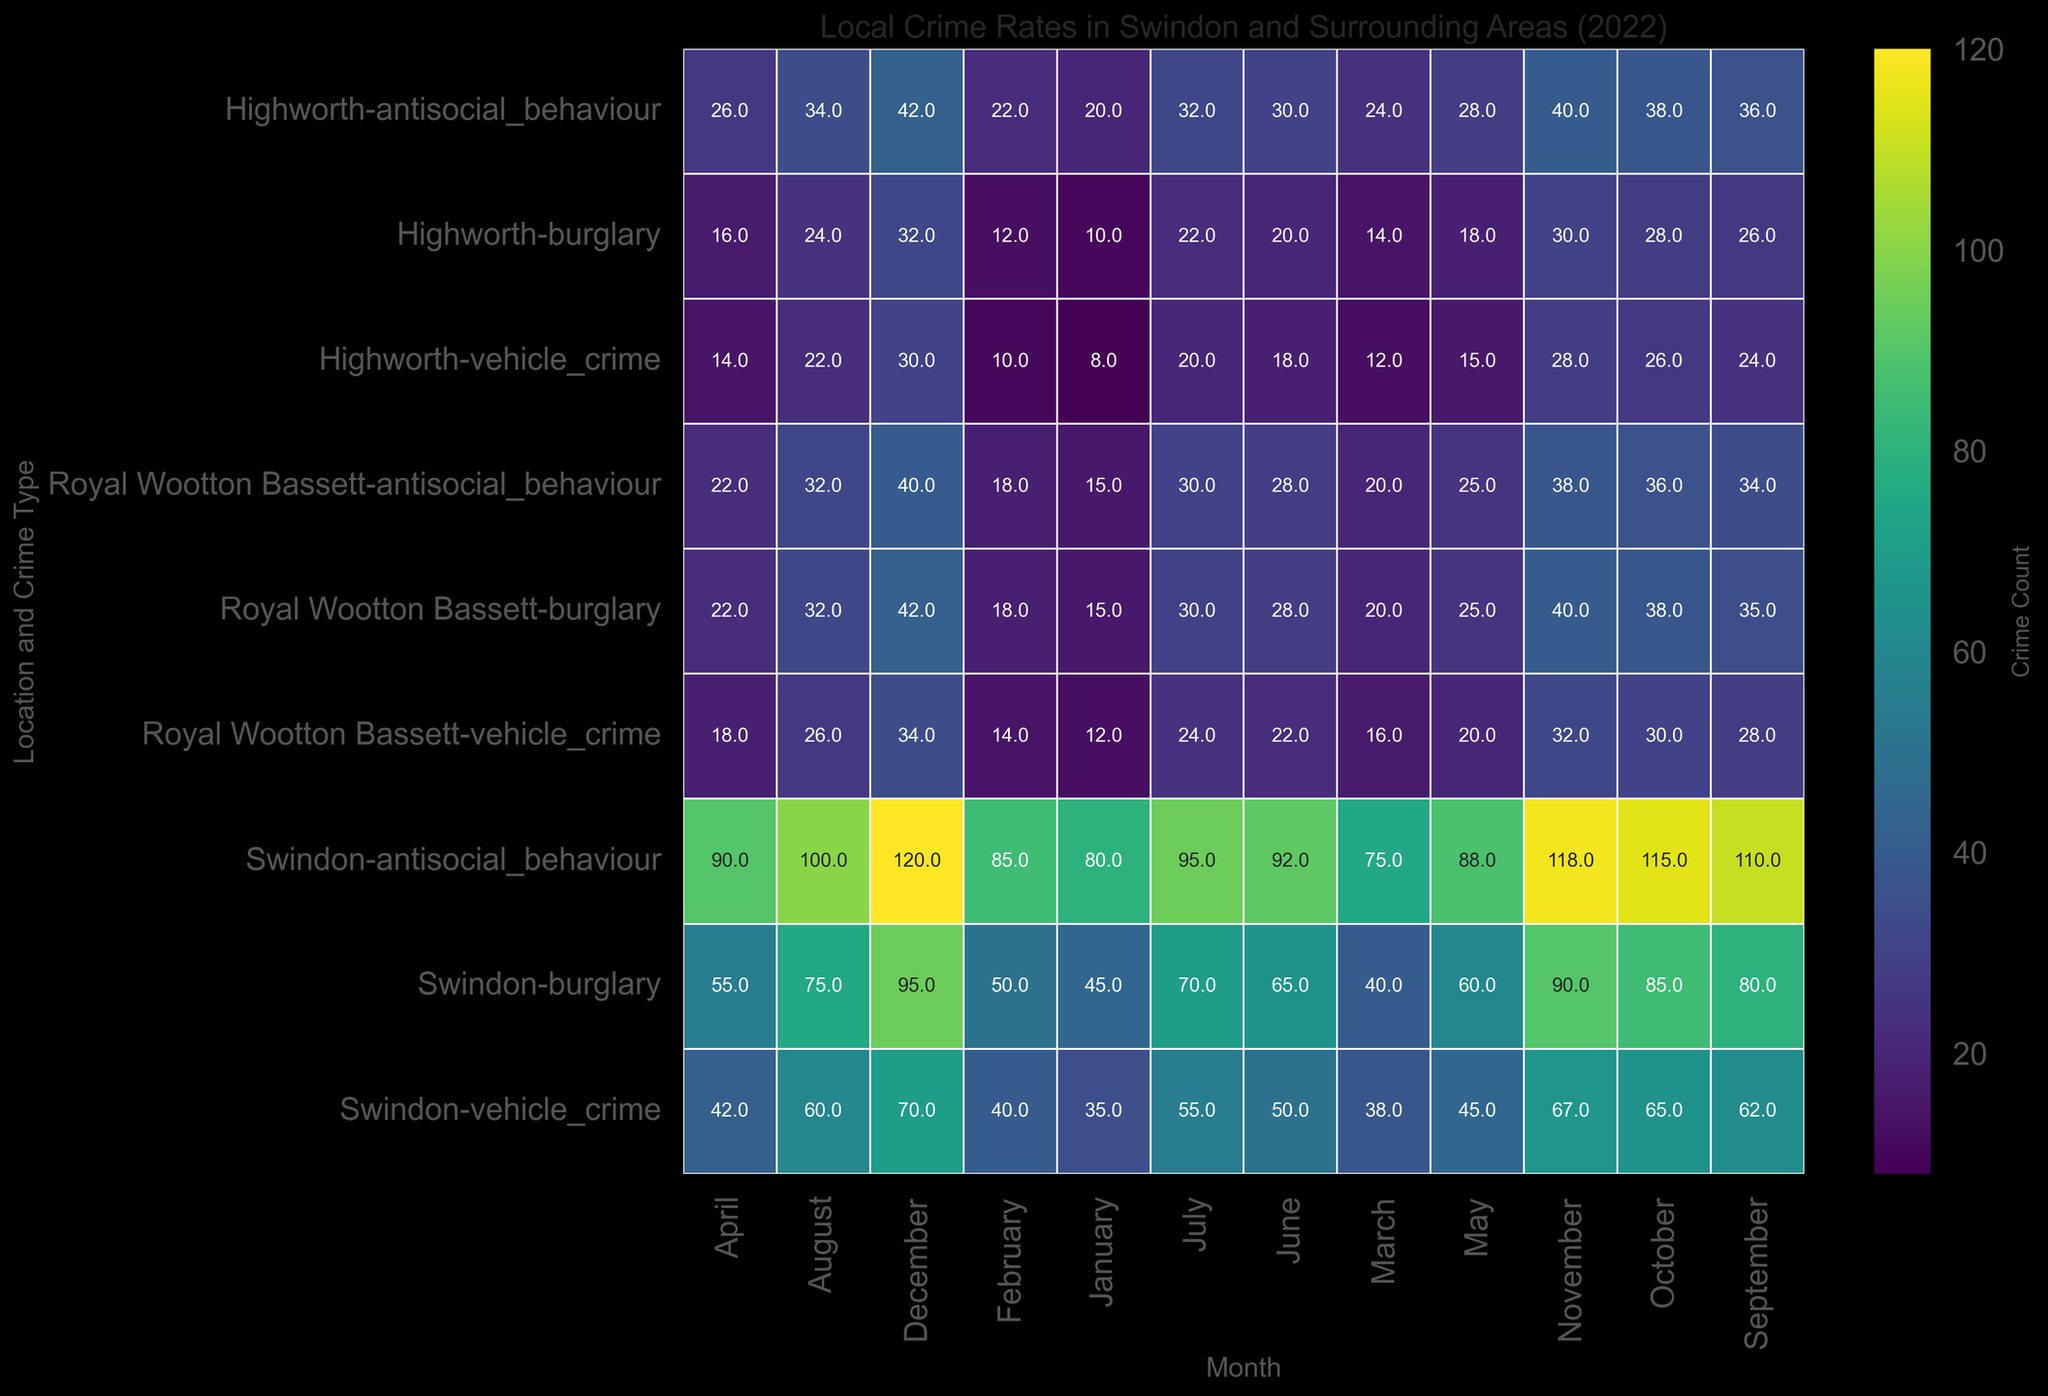What's the highest number of burglaries in Swindon during 2022? Look for the darkest shade within the burglary rows for Swindon in the heatmap. December has the darkest shade, which corresponds to the highest value seen (95).
Answer: 95 Which location had the highest anti-social behaviour incidents in August 2022? Focus on the anti-social behaviour row for August and identify the darkest cell. Swindon has the darkest cell, signifying the highest count.
Answer: Swindon Compare the number of vehicle crimes in Royal Wootton Bassett in January and December 2022. Which month had more vehicle crimes? Compare the shades and values of the months January and December in the vehicle crime row for Royal Wootton Bassett. December has a higher count (34) compared to January (12).
Answer: December Did Highworth experience less anti-social behaviour or vehicle crimes on average in 2022? Calculate the average anti-social behaviour (sum of all monthly counts divided by 12) and the average vehicle crime (sum of all monthly counts divided by 12) for Highworth. Anti-social behaviour has a higher count compared to vehicle crimes based on initial observations.
Answer: Vehicle crimes What is the total number of burglaries for Swindon in the first quarter of 2022? Add the values for January, February, and March from the burglary row for Swindon. 45 + 50 + 40 = 135.
Answer: 135 Which crime type had the highest total count in Royal Wootton Bassett in 2022? Sum the counts for each crime type in Royal Wootton Bassett across all months. Anti-social behaviour appears to have the highest count based on the average shades and numbers observed.
Answer: Anti-social behaviour In which month did Swindon have the lowest vehicle crime rate in 2022? Look for the lightest shade in the vehicle crime row for Swindon. The lightest shade is found in January (35).
Answer: January How did the number of burglaries change from June to December in Highworth? Subtract the count of burglaries in June (20) from December (32) for Highworth, which results in an increase of 12.
Answer: Increased by 12 Compare the overall crime trend in Swindon for anti-social behaviour and vehicle crimes in 2022. Observe the trend lines for anti-social behaviour and vehicle crimes across all months for Swindon. There is a noticeable increasing trend for both, but anti-social behaviour increases more sharply.
Answer: Both increase, but anti-social behaviour increases more sharply What month recorded the maximum vehicle crime rate in Swindon, and what was the count? Identify the darkest cell in the vehicle crime row for Swindon. The darkest cell is in December with a count of 70.
Answer: December, 70 